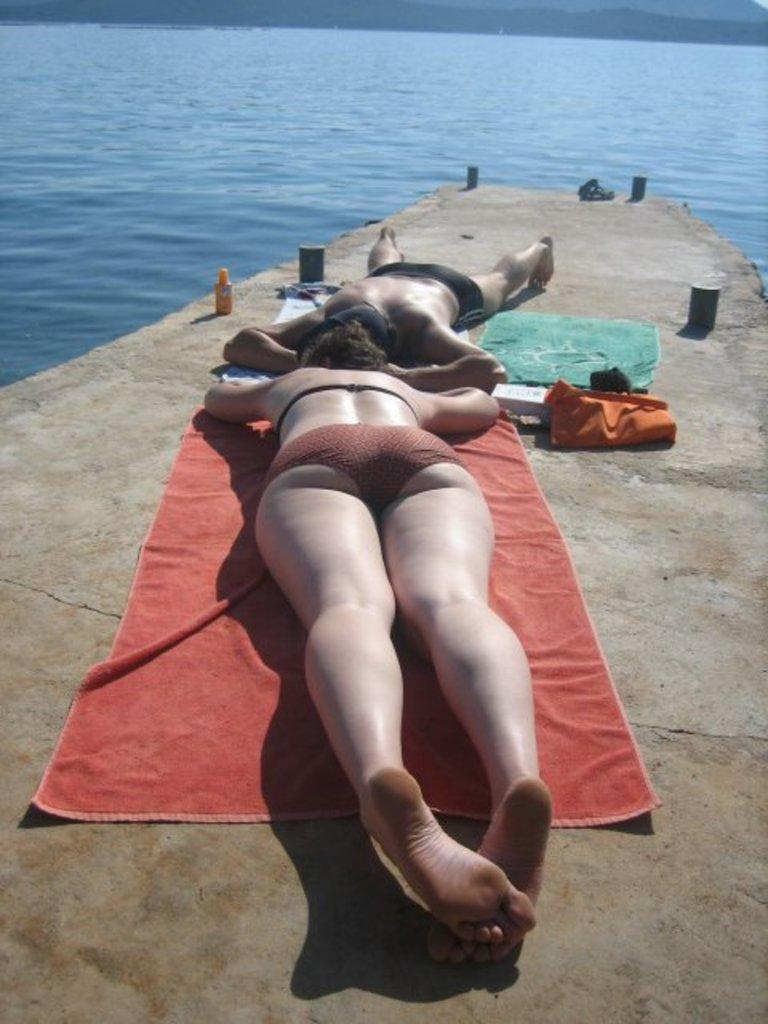What are the two persons in the image doing? The two persons are lying on the floor. What can be seen related to Mars in the image? There are objects related to Mars in the image. What is visible in the background of the image? There is water visible in the background of the image. What type of beef is being served to the crow in the image? There is no beef or crow present in the image. 